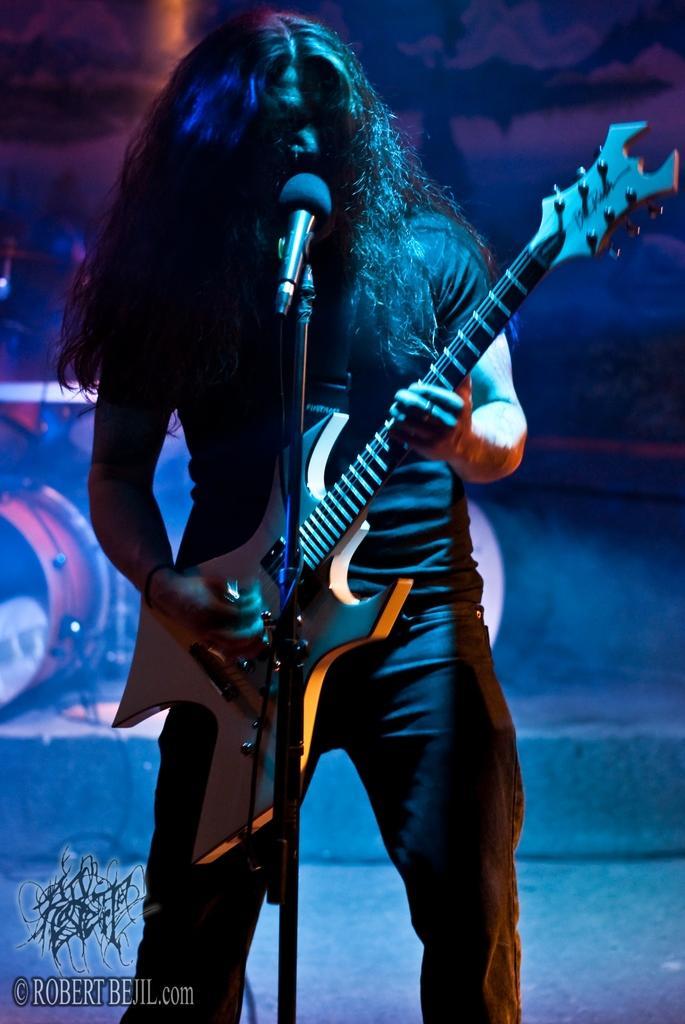Describe this image in one or two sentences. In this image I can see a person standing and playing the guitar. In front of this person there is a mike stand. On the left side there is a drum set. The background is in black color. In the bottom left there is some edited text. 